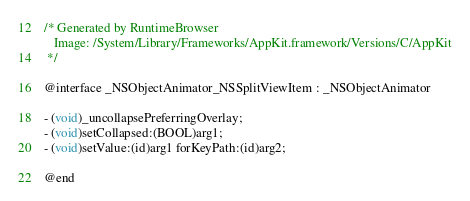Convert code to text. <code><loc_0><loc_0><loc_500><loc_500><_C_>/* Generated by RuntimeBrowser
   Image: /System/Library/Frameworks/AppKit.framework/Versions/C/AppKit
 */

@interface _NSObjectAnimator_NSSplitViewItem : _NSObjectAnimator

- (void)_uncollapsePreferringOverlay;
- (void)setCollapsed:(BOOL)arg1;
- (void)setValue:(id)arg1 forKeyPath:(id)arg2;

@end
</code> 